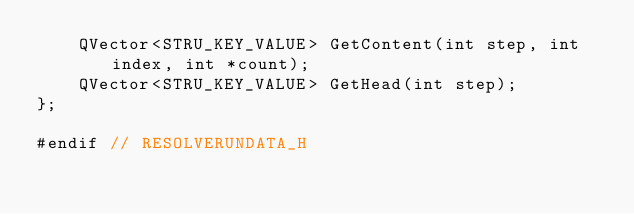Convert code to text. <code><loc_0><loc_0><loc_500><loc_500><_C_>    QVector<STRU_KEY_VALUE> GetContent(int step, int index, int *count);
    QVector<STRU_KEY_VALUE> GetHead(int step);
};

#endif // RESOLVERUNDATA_H
</code> 